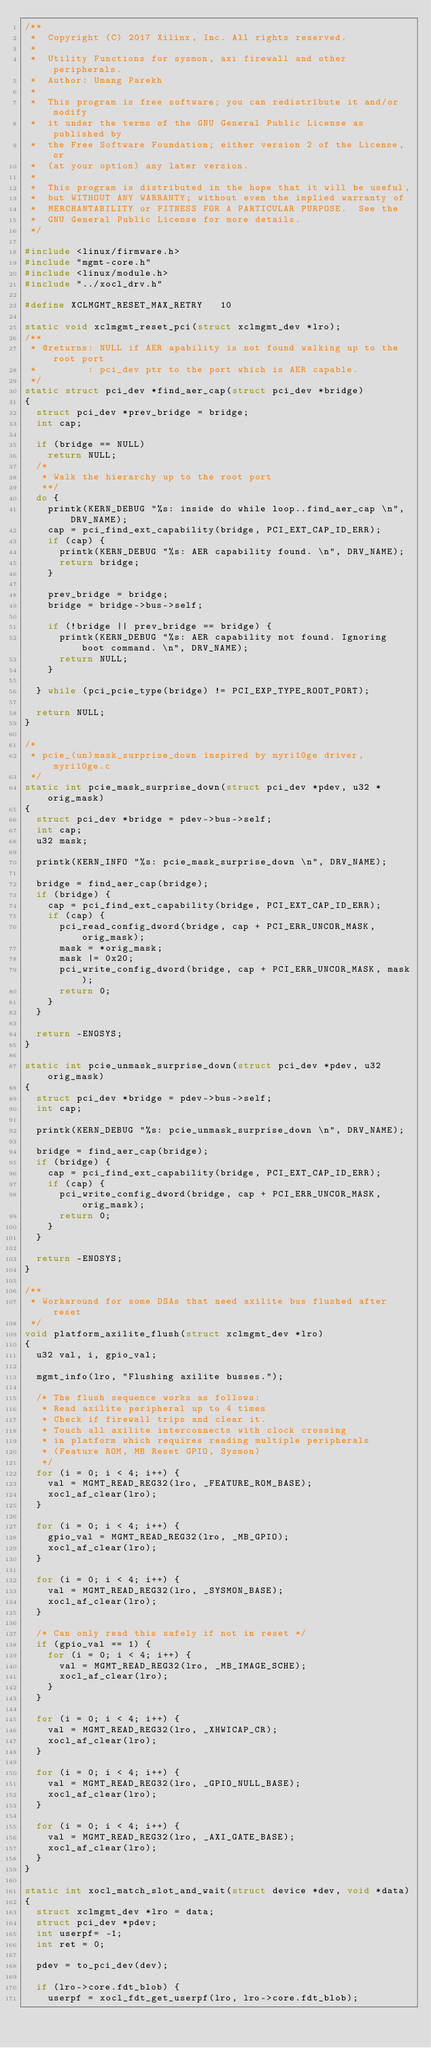<code> <loc_0><loc_0><loc_500><loc_500><_C_>/**
 *  Copyright (C) 2017 Xilinx, Inc. All rights reserved.
 *
 *  Utility Functions for sysmon, axi firewall and other peripherals.
 *  Author: Umang Parekh
 *
 *  This program is free software; you can redistribute it and/or modify
 *  it under the terms of the GNU General Public License as published by
 *  the Free Software Foundation; either version 2 of the License, or
 *  (at your option) any later version.
 *
 *  This program is distributed in the hope that it will be useful,
 *  but WITHOUT ANY WARRANTY; without even the implied warranty of
 *  MERCHANTABILITY or FITNESS FOR A PARTICULAR PURPOSE.  See the
 *  GNU General Public License for more details.
 */

#include <linux/firmware.h>
#include "mgmt-core.h"
#include <linux/module.h>
#include "../xocl_drv.h"

#define XCLMGMT_RESET_MAX_RETRY		10

static void xclmgmt_reset_pci(struct xclmgmt_dev *lro);
/**
 * @returns: NULL if AER apability is not found walking up to the root port
 *         : pci_dev ptr to the port which is AER capable.
 */
static struct pci_dev *find_aer_cap(struct pci_dev *bridge)
{
	struct pci_dev *prev_bridge = bridge;
	int cap;

	if (bridge == NULL)
		return NULL;
	/*
	 * Walk the hierarchy up to the root port
	 **/
	do {
		printk(KERN_DEBUG "%s: inside do while loop..find_aer_cap \n", DRV_NAME);
		cap = pci_find_ext_capability(bridge, PCI_EXT_CAP_ID_ERR);
		if (cap) {
			printk(KERN_DEBUG "%s: AER capability found. \n", DRV_NAME);
			return bridge;
		}

		prev_bridge = bridge;
		bridge = bridge->bus->self;

		if (!bridge || prev_bridge == bridge) {
			printk(KERN_DEBUG "%s: AER capability not found. Ignoring boot command. \n", DRV_NAME);
			return NULL;
		}

	} while (pci_pcie_type(bridge) != PCI_EXP_TYPE_ROOT_PORT);

	return NULL;
}

/*
 * pcie_(un)mask_surprise_down inspired by myri10ge driver, myri10ge.c
 */
static int pcie_mask_surprise_down(struct pci_dev *pdev, u32 *orig_mask)
{
	struct pci_dev *bridge = pdev->bus->self;
	int cap;
	u32 mask;

	printk(KERN_INFO "%s: pcie_mask_surprise_down \n", DRV_NAME);

	bridge = find_aer_cap(bridge);
	if (bridge) {
		cap = pci_find_ext_capability(bridge, PCI_EXT_CAP_ID_ERR);
		if (cap) {
			pci_read_config_dword(bridge, cap + PCI_ERR_UNCOR_MASK, orig_mask);
			mask = *orig_mask;
			mask |= 0x20;
			pci_write_config_dword(bridge, cap + PCI_ERR_UNCOR_MASK, mask);
			return 0;
		}
	}

	return -ENOSYS;
}

static int pcie_unmask_surprise_down(struct pci_dev *pdev, u32 orig_mask)
{
	struct pci_dev *bridge = pdev->bus->self;
	int cap;

	printk(KERN_DEBUG "%s: pcie_unmask_surprise_down \n", DRV_NAME);

	bridge = find_aer_cap(bridge);
	if (bridge) {
		cap = pci_find_ext_capability(bridge, PCI_EXT_CAP_ID_ERR);
		if (cap) {
			pci_write_config_dword(bridge, cap + PCI_ERR_UNCOR_MASK, orig_mask);
			return 0;
		}
	}

	return -ENOSYS;
}

/**
 * Workaround for some DSAs that need axilite bus flushed after reset
 */
void platform_axilite_flush(struct xclmgmt_dev *lro)
{
	u32 val, i, gpio_val;

	mgmt_info(lro, "Flushing axilite busses.");

	/* The flush sequence works as follows:
	 * Read axilite peripheral up to 4 times
	 * Check if firewall trips and clear it.
	 * Touch all axilite interconnects with clock crossing
	 * in platform which requires reading multiple peripherals
	 * (Feature ROM, MB Reset GPIO, Sysmon)
	 */
	for (i = 0; i < 4; i++) {
		val = MGMT_READ_REG32(lro, _FEATURE_ROM_BASE);
		xocl_af_clear(lro);
	}

	for (i = 0; i < 4; i++) {
		gpio_val = MGMT_READ_REG32(lro, _MB_GPIO);
		xocl_af_clear(lro);
	}

	for (i = 0; i < 4; i++) {
		val = MGMT_READ_REG32(lro, _SYSMON_BASE);
		xocl_af_clear(lro);
	}

	/* Can only read this safely if not in reset */
	if (gpio_val == 1) {
		for (i = 0; i < 4; i++) {
			val = MGMT_READ_REG32(lro, _MB_IMAGE_SCHE);
			xocl_af_clear(lro);
		}
	}

	for (i = 0; i < 4; i++) {
		val = MGMT_READ_REG32(lro, _XHWICAP_CR);
		xocl_af_clear(lro);
	}

	for (i = 0; i < 4; i++) {
		val = MGMT_READ_REG32(lro, _GPIO_NULL_BASE);
		xocl_af_clear(lro);
	}

	for (i = 0; i < 4; i++) {
		val = MGMT_READ_REG32(lro, _AXI_GATE_BASE);
		xocl_af_clear(lro);
	}
}

static int xocl_match_slot_and_wait(struct device *dev, void *data)
{
	struct xclmgmt_dev *lro = data;
	struct pci_dev *pdev;
	int userpf= -1;
	int ret = 0;

	pdev = to_pci_dev(dev);

	if (lro->core.fdt_blob) {
		userpf = xocl_fdt_get_userpf(lro, lro->core.fdt_blob);</code> 